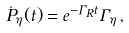<formula> <loc_0><loc_0><loc_500><loc_500>\dot { P } _ { \eta } ( t ) = e ^ { - \Gamma _ { R } t } \Gamma _ { \eta } \, ,</formula> 